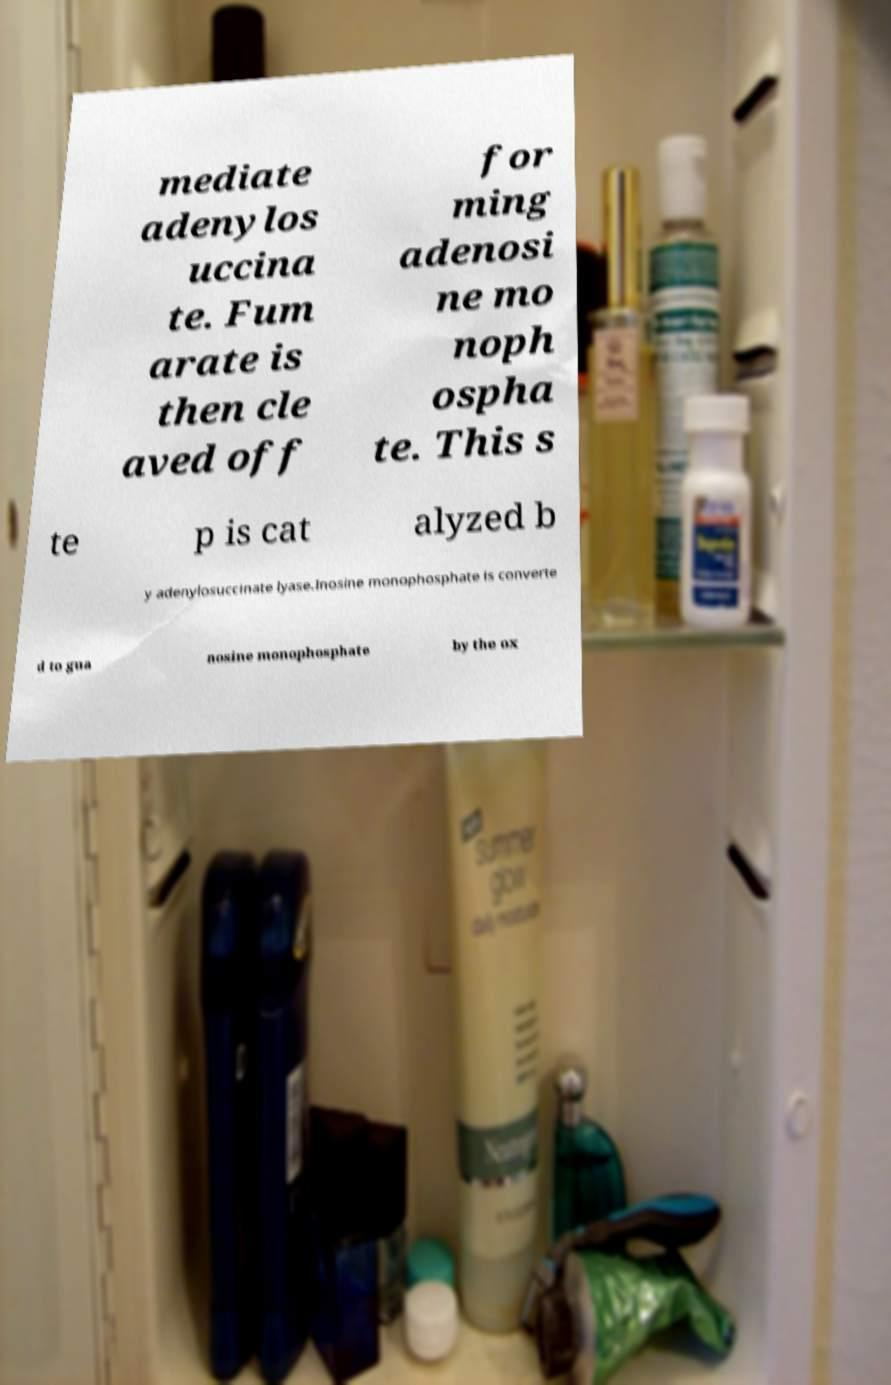Could you extract and type out the text from this image? mediate adenylos uccina te. Fum arate is then cle aved off for ming adenosi ne mo noph ospha te. This s te p is cat alyzed b y adenylosuccinate lyase.Inosine monophosphate is converte d to gua nosine monophosphate by the ox 